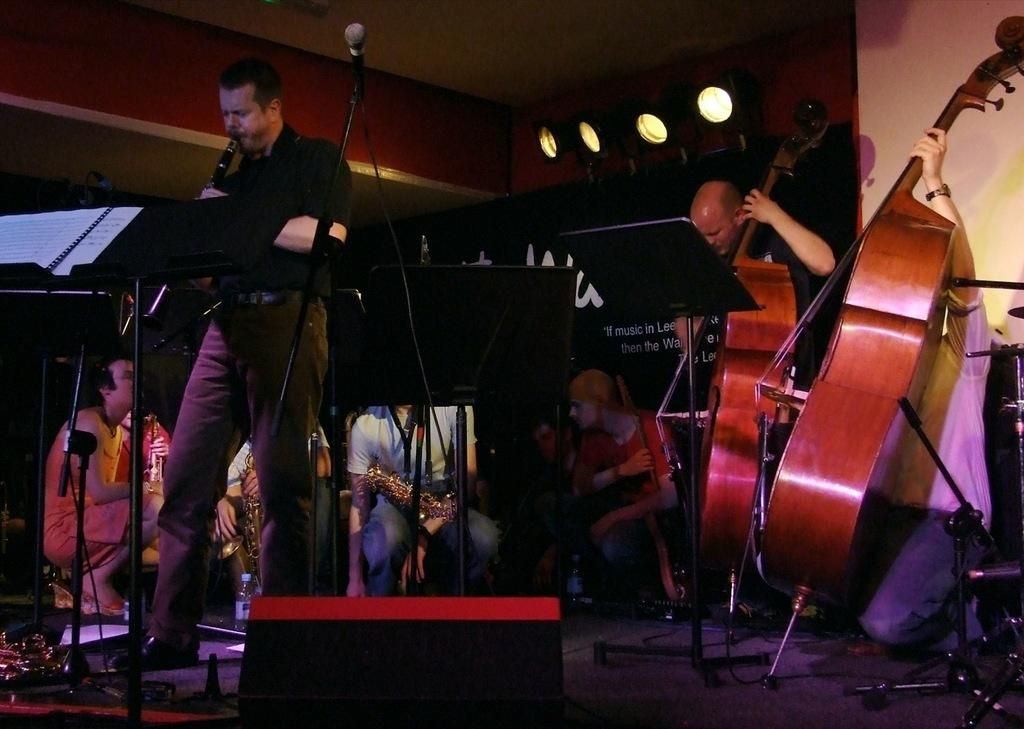What is happening in the image? There is a group of people in the image, and they are playing musical instruments. What are the people doing in the image? The people are playing musical instruments. Can you see an airplane flying in the background of the image? There is no airplane visible in the image; it only shows a group of people playing musical instruments. 